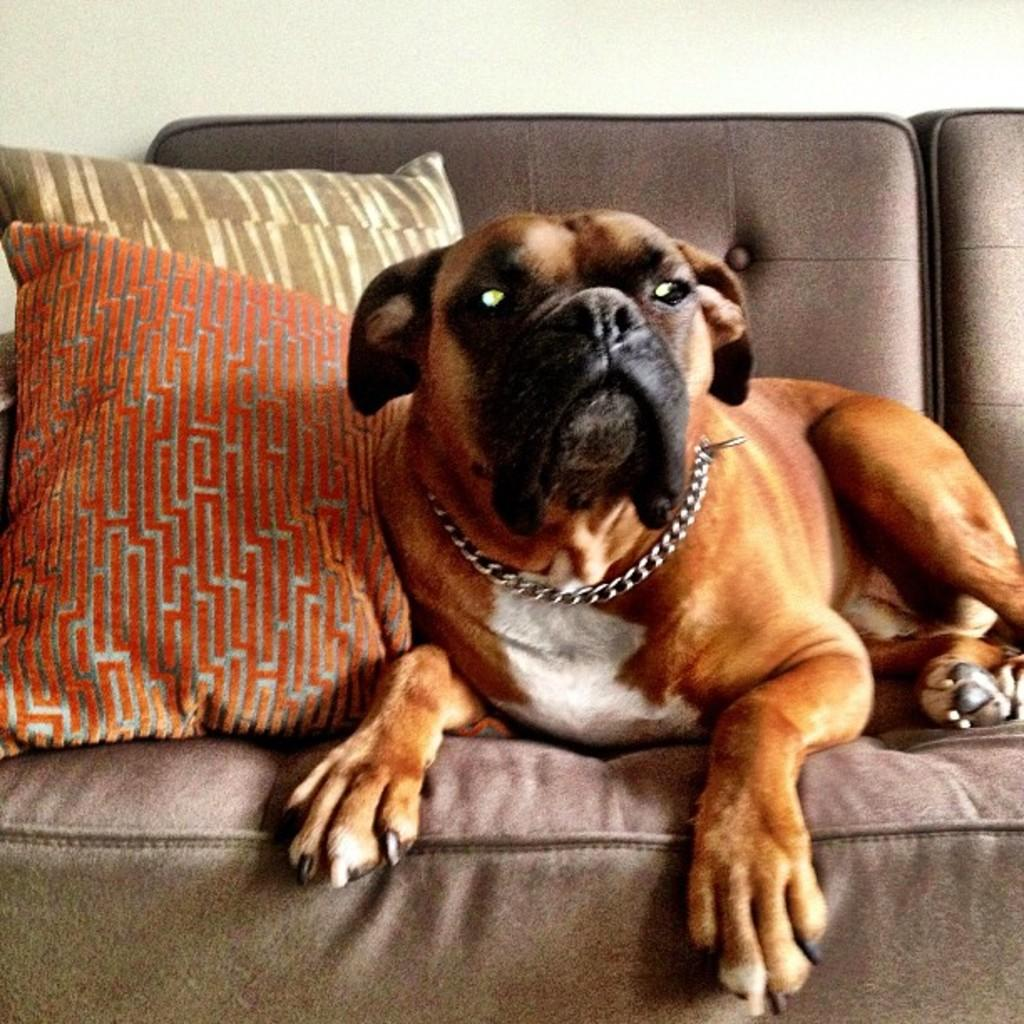What type of animal is present in the image? There is a dog in the image. What type of furniture is visible in the image? There are cushions on the sofa in the image. How many boys are playing on the seashore in the image? There is no seashore or boys present in the image; it only features a dog and a sofa with cushions. 